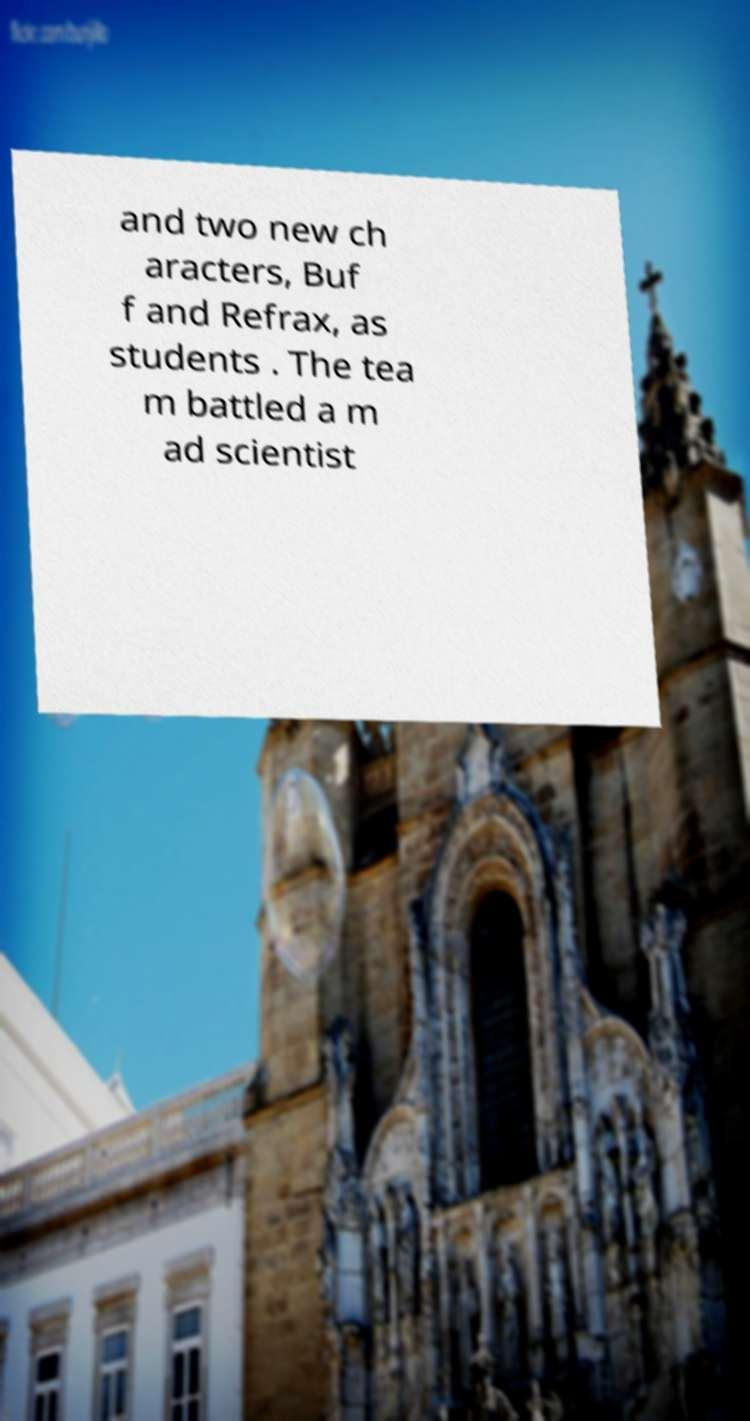Please read and relay the text visible in this image. What does it say? and two new ch aracters, Buf f and Refrax, as students . The tea m battled a m ad scientist 